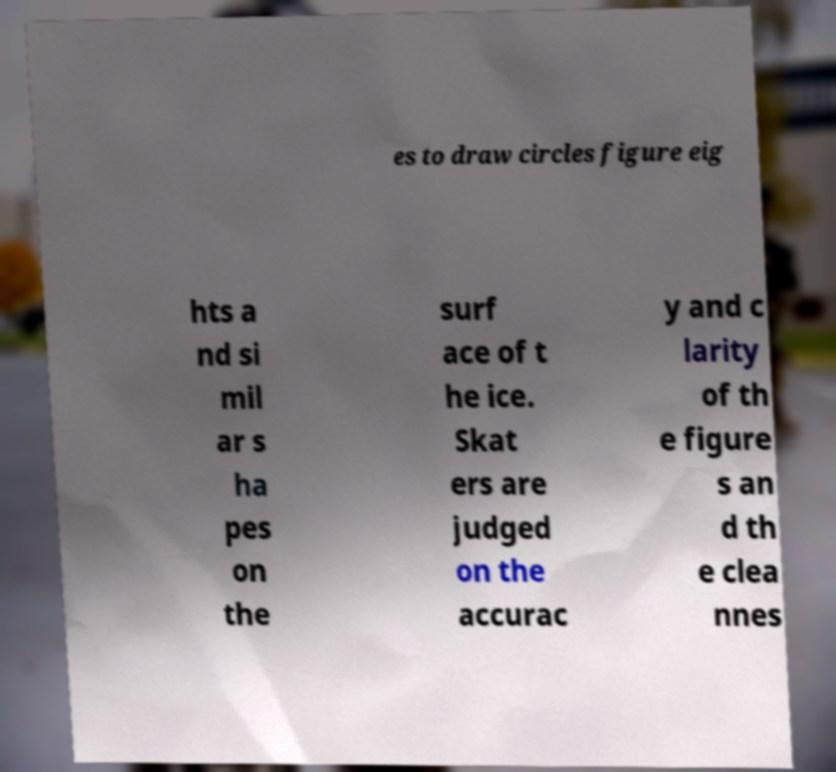Please read and relay the text visible in this image. What does it say? es to draw circles figure eig hts a nd si mil ar s ha pes on the surf ace of t he ice. Skat ers are judged on the accurac y and c larity of th e figure s an d th e clea nnes 